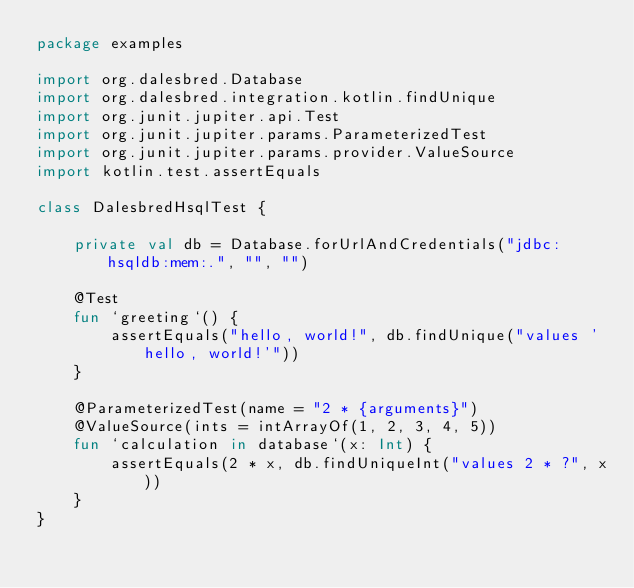Convert code to text. <code><loc_0><loc_0><loc_500><loc_500><_Kotlin_>package examples

import org.dalesbred.Database
import org.dalesbred.integration.kotlin.findUnique
import org.junit.jupiter.api.Test
import org.junit.jupiter.params.ParameterizedTest
import org.junit.jupiter.params.provider.ValueSource
import kotlin.test.assertEquals

class DalesbredHsqlTest {

    private val db = Database.forUrlAndCredentials("jdbc:hsqldb:mem:.", "", "")

    @Test
    fun `greeting`() {
        assertEquals("hello, world!", db.findUnique("values 'hello, world!'"))
    }

    @ParameterizedTest(name = "2 * {arguments}")
    @ValueSource(ints = intArrayOf(1, 2, 3, 4, 5))
    fun `calculation in database`(x: Int) {
        assertEquals(2 * x, db.findUniqueInt("values 2 * ?", x))
    }
}
</code> 